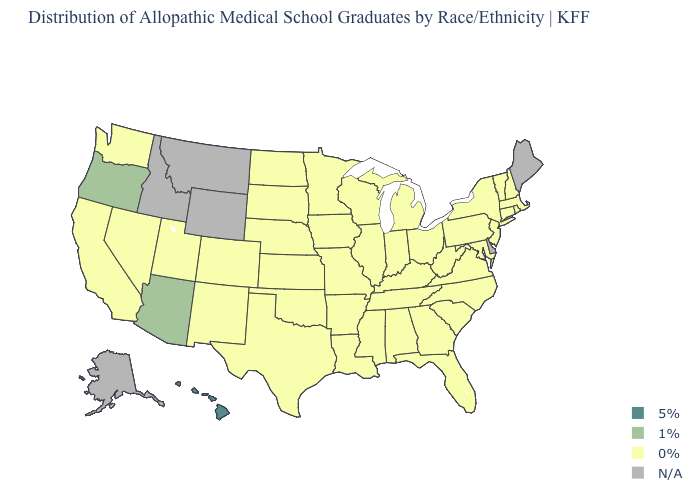What is the lowest value in the USA?
Quick response, please. 0%. Name the states that have a value in the range 0%?
Write a very short answer. Alabama, Arkansas, California, Colorado, Connecticut, Florida, Georgia, Illinois, Indiana, Iowa, Kansas, Kentucky, Louisiana, Maryland, Massachusetts, Michigan, Minnesota, Mississippi, Missouri, Nebraska, Nevada, New Hampshire, New Jersey, New Mexico, New York, North Carolina, North Dakota, Ohio, Oklahoma, Pennsylvania, Rhode Island, South Carolina, South Dakota, Tennessee, Texas, Utah, Vermont, Virginia, Washington, West Virginia, Wisconsin. What is the value of Maine?
Quick response, please. N/A. Does the first symbol in the legend represent the smallest category?
Quick response, please. No. What is the lowest value in the USA?
Keep it brief. 0%. Which states have the highest value in the USA?
Give a very brief answer. Hawaii. What is the lowest value in states that border Idaho?
Write a very short answer. 0%. Among the states that border Montana , which have the highest value?
Keep it brief. North Dakota, South Dakota. What is the highest value in the MidWest ?
Write a very short answer. 0%. What is the value of Minnesota?
Give a very brief answer. 0%. What is the value of Mississippi?
Quick response, please. 0%. What is the highest value in states that border New Mexico?
Keep it brief. 1%. 